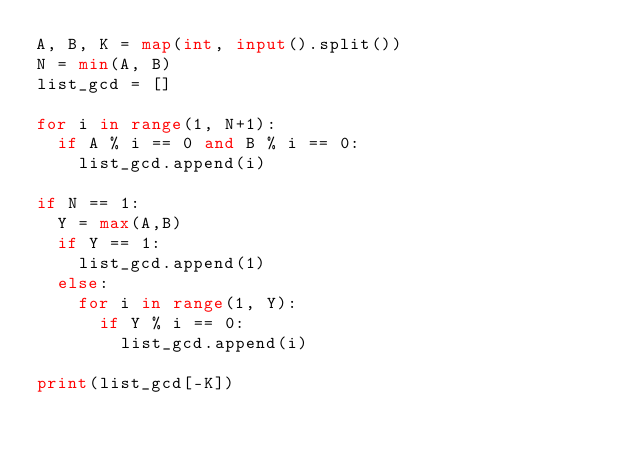Convert code to text. <code><loc_0><loc_0><loc_500><loc_500><_Python_>A, B, K = map(int, input().split())
N = min(A, B)
list_gcd = [] 

for i in range(1, N+1):
  if A % i == 0 and B % i == 0:
    list_gcd.append(i)
    
if N == 1:
  Y = max(A,B)
  if Y == 1:
    list_gcd.append(1)
  else:
    for i in range(1, Y):
      if Y % i == 0:
        list_gcd.append(i)

print(list_gcd[-K])</code> 